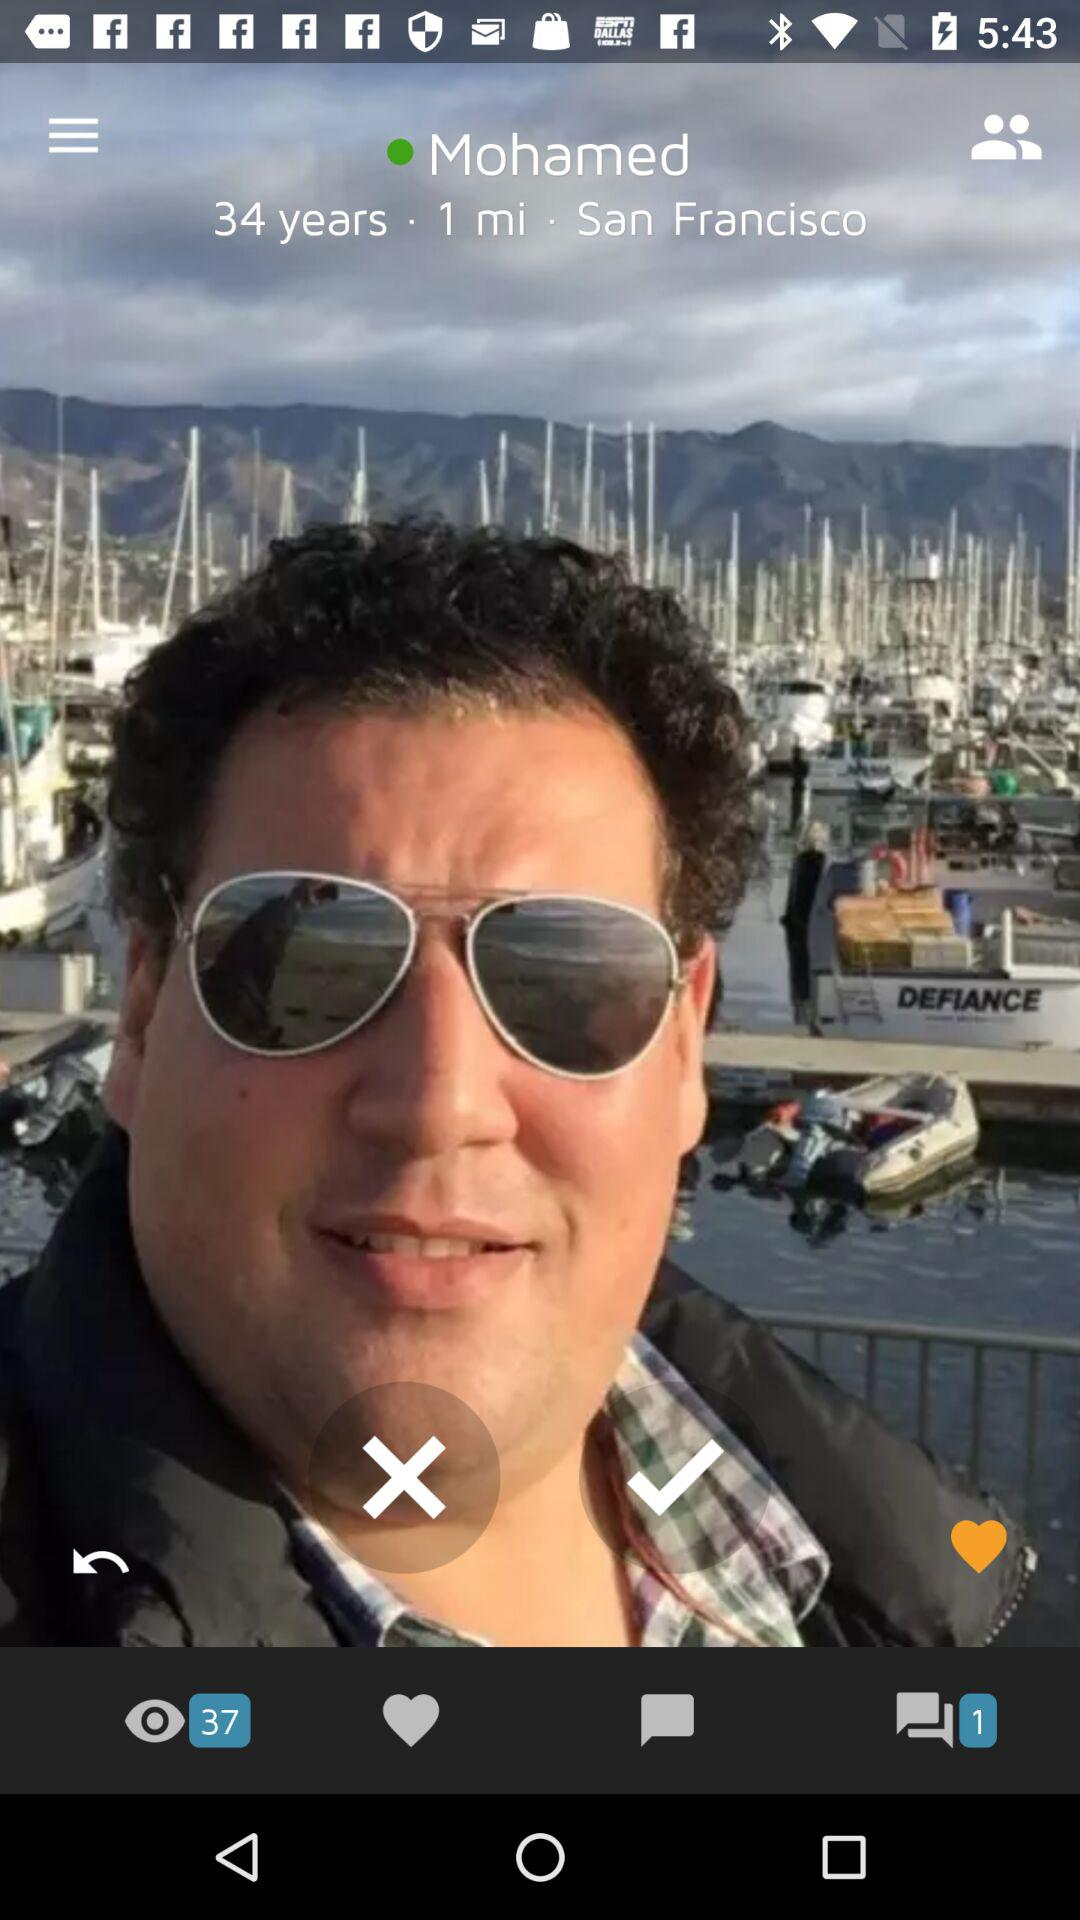What is the age of the person? The person is 34 years old. 